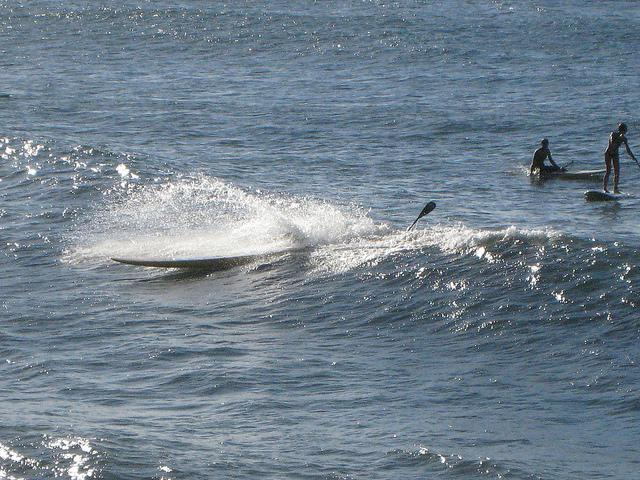What is below the paddle shown here?

Choices:
A) whale
B) person
C) dolphin
D) land shark person 